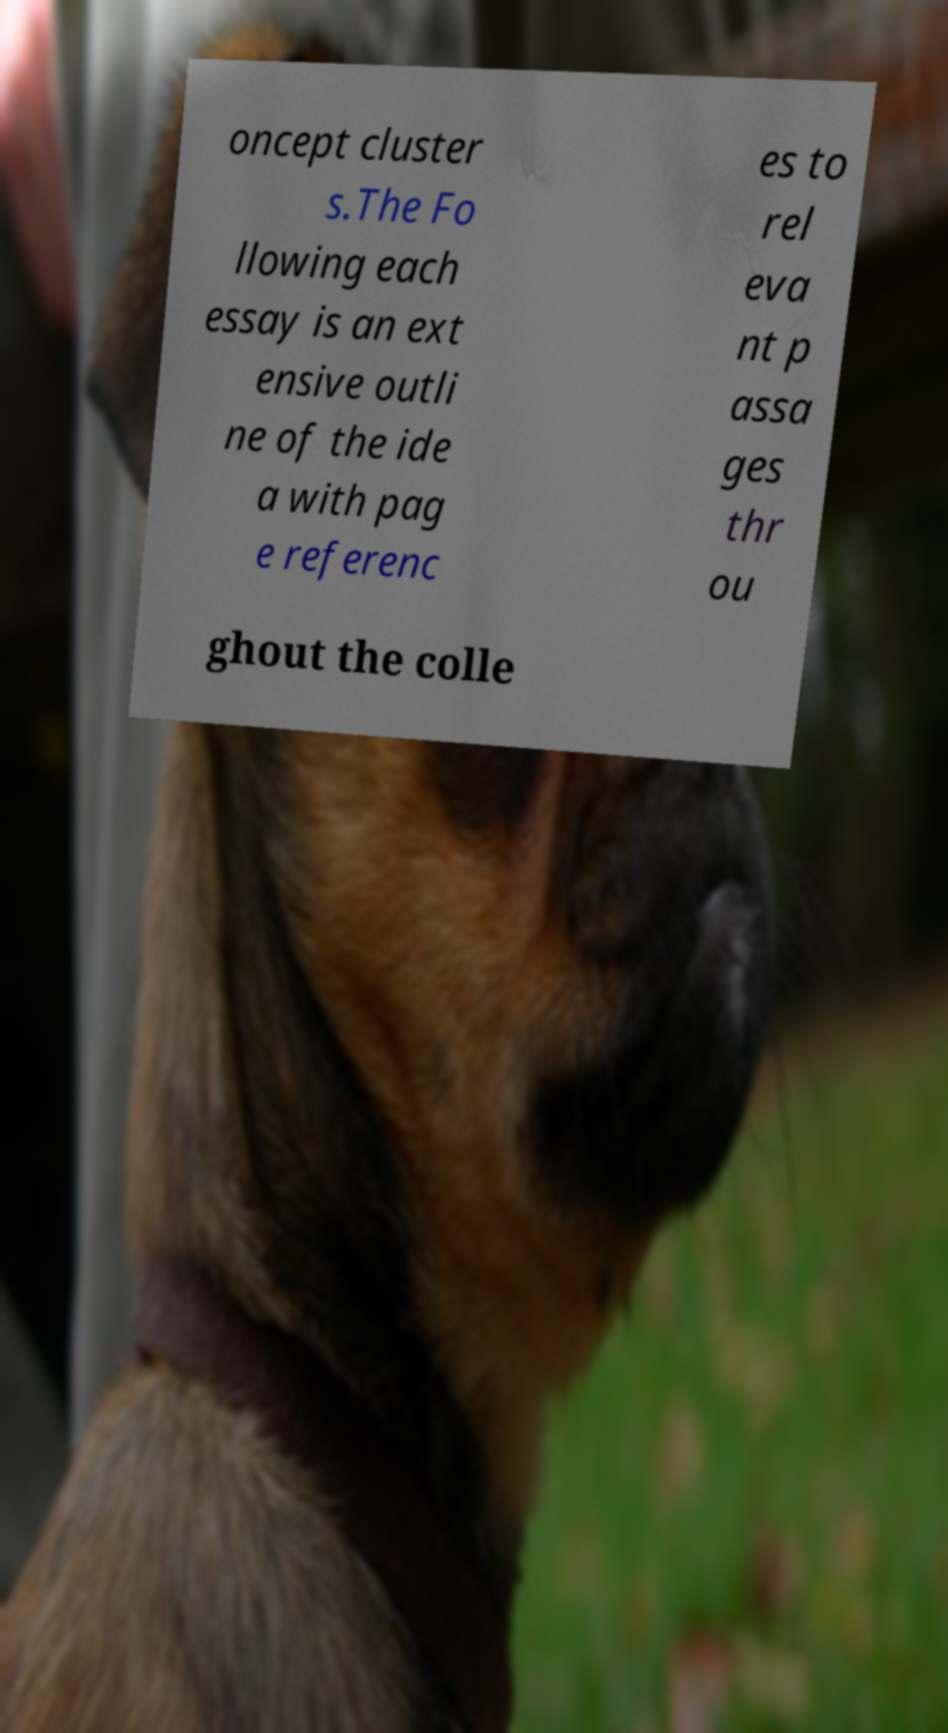Please read and relay the text visible in this image. What does it say? oncept cluster s.The Fo llowing each essay is an ext ensive outli ne of the ide a with pag e referenc es to rel eva nt p assa ges thr ou ghout the colle 